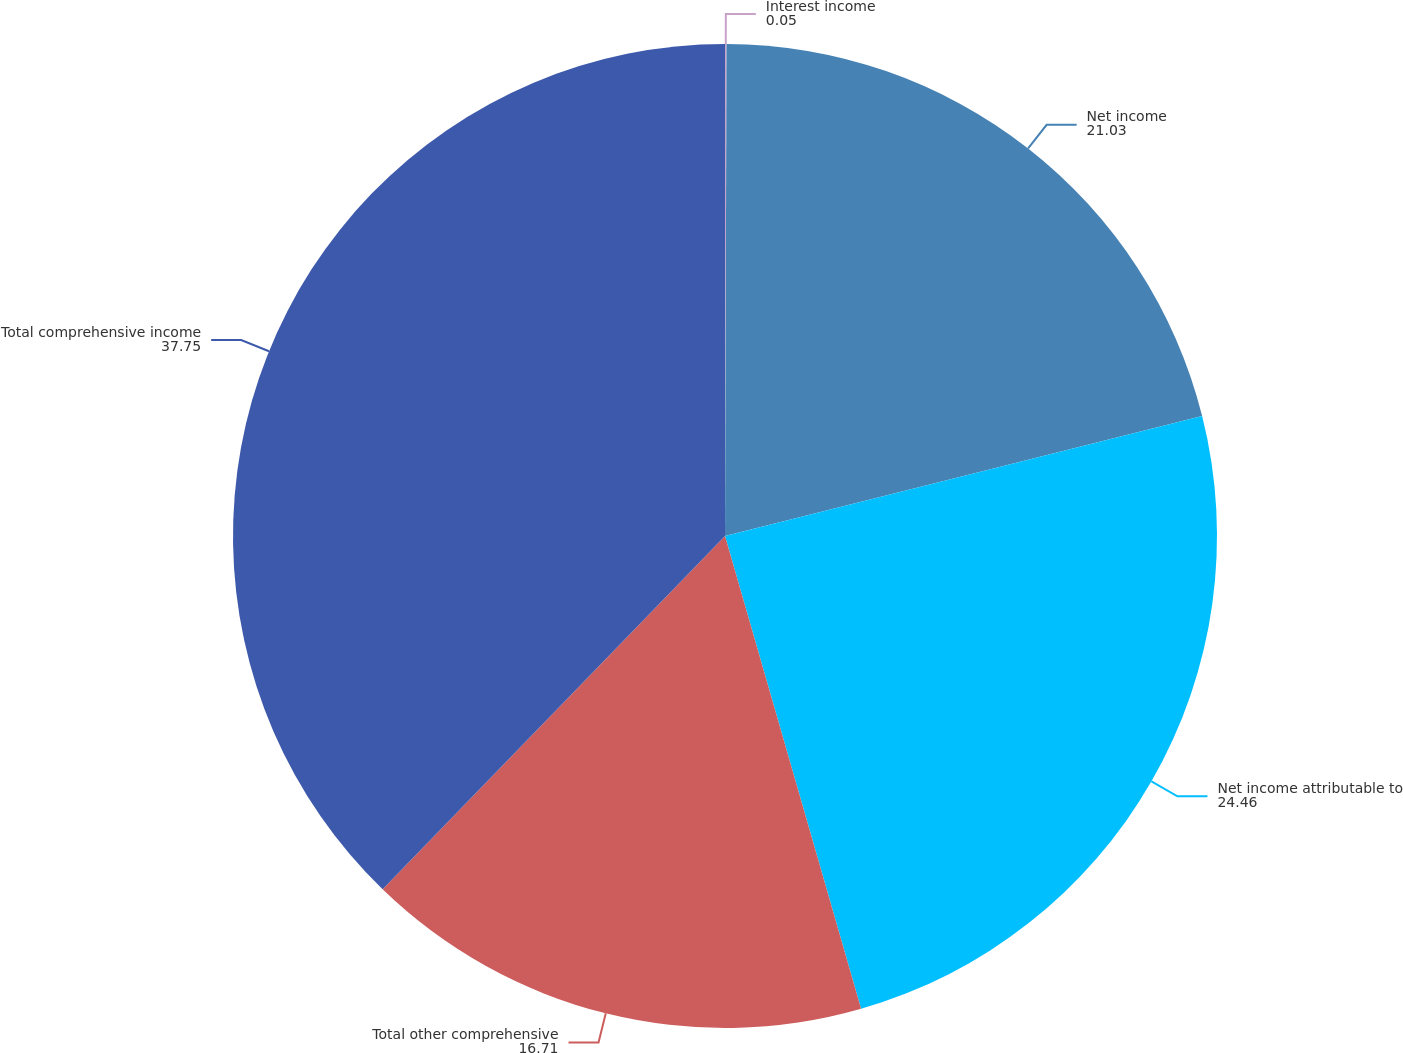Convert chart to OTSL. <chart><loc_0><loc_0><loc_500><loc_500><pie_chart><fcel>Interest income<fcel>Net income<fcel>Net income attributable to<fcel>Total other comprehensive<fcel>Total comprehensive income<nl><fcel>0.05%<fcel>21.03%<fcel>24.46%<fcel>16.71%<fcel>37.75%<nl></chart> 